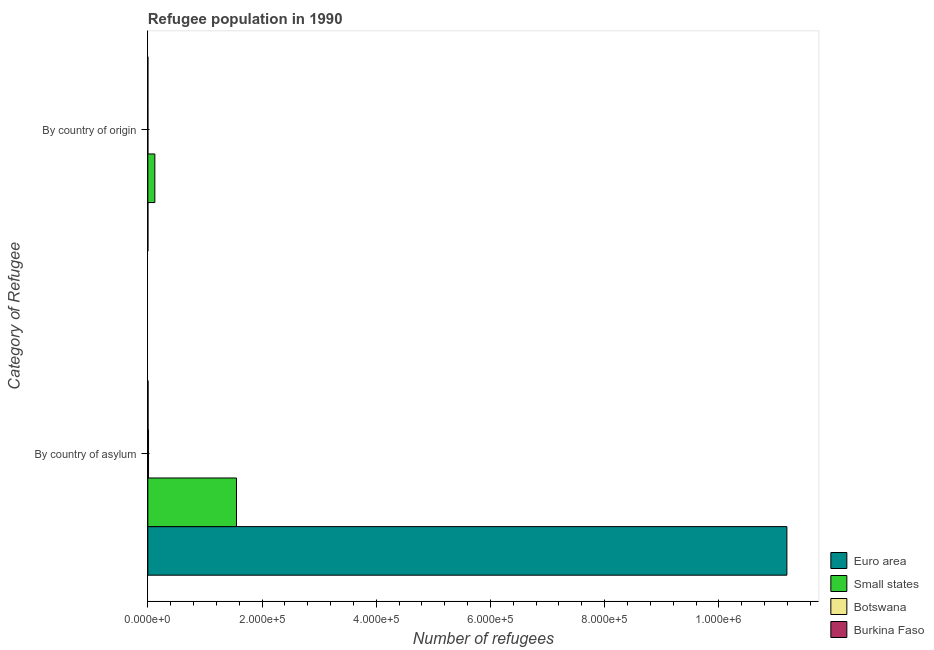Are the number of bars per tick equal to the number of legend labels?
Make the answer very short. Yes. Are the number of bars on each tick of the Y-axis equal?
Your answer should be compact. Yes. How many bars are there on the 2nd tick from the top?
Keep it short and to the point. 4. How many bars are there on the 1st tick from the bottom?
Give a very brief answer. 4. What is the label of the 1st group of bars from the top?
Keep it short and to the point. By country of origin. What is the number of refugees by country of origin in Botswana?
Ensure brevity in your answer.  3. Across all countries, what is the maximum number of refugees by country of asylum?
Ensure brevity in your answer.  1.12e+06. Across all countries, what is the minimum number of refugees by country of origin?
Make the answer very short. 2. In which country was the number of refugees by country of origin maximum?
Your response must be concise. Small states. In which country was the number of refugees by country of origin minimum?
Provide a succinct answer. Burkina Faso. What is the total number of refugees by country of origin in the graph?
Provide a succinct answer. 1.23e+04. What is the difference between the number of refugees by country of origin in Euro area and that in Small states?
Your answer should be very brief. -1.22e+04. What is the difference between the number of refugees by country of origin in Small states and the number of refugees by country of asylum in Euro area?
Provide a short and direct response. -1.11e+06. What is the average number of refugees by country of asylum per country?
Offer a terse response. 3.19e+05. What is the difference between the number of refugees by country of asylum and number of refugees by country of origin in Euro area?
Offer a very short reply. 1.12e+06. In how many countries, is the number of refugees by country of asylum greater than 720000 ?
Your answer should be very brief. 1. What is the ratio of the number of refugees by country of origin in Small states to that in Burkina Faso?
Your answer should be compact. 6122.5. Is the number of refugees by country of asylum in Botswana less than that in Euro area?
Provide a succinct answer. Yes. What does the 3rd bar from the top in By country of asylum represents?
Offer a terse response. Small states. What does the 3rd bar from the bottom in By country of asylum represents?
Keep it short and to the point. Botswana. How many bars are there?
Give a very brief answer. 8. How many countries are there in the graph?
Provide a short and direct response. 4. What is the difference between two consecutive major ticks on the X-axis?
Ensure brevity in your answer.  2.00e+05. Does the graph contain any zero values?
Offer a terse response. No. Does the graph contain grids?
Provide a succinct answer. No. Where does the legend appear in the graph?
Your answer should be compact. Bottom right. How many legend labels are there?
Offer a terse response. 4. What is the title of the graph?
Keep it short and to the point. Refugee population in 1990. What is the label or title of the X-axis?
Keep it short and to the point. Number of refugees. What is the label or title of the Y-axis?
Provide a short and direct response. Category of Refugee. What is the Number of refugees in Euro area in By country of asylum?
Ensure brevity in your answer.  1.12e+06. What is the Number of refugees of Small states in By country of asylum?
Make the answer very short. 1.55e+05. What is the Number of refugees of Botswana in By country of asylum?
Provide a succinct answer. 1179. What is the Number of refugees in Burkina Faso in By country of asylum?
Give a very brief answer. 350. What is the Number of refugees in Small states in By country of origin?
Your answer should be compact. 1.22e+04. What is the Number of refugees of Botswana in By country of origin?
Your response must be concise. 3. What is the Number of refugees of Burkina Faso in By country of origin?
Offer a very short reply. 2. Across all Category of Refugee, what is the maximum Number of refugees of Euro area?
Give a very brief answer. 1.12e+06. Across all Category of Refugee, what is the maximum Number of refugees of Small states?
Provide a short and direct response. 1.55e+05. Across all Category of Refugee, what is the maximum Number of refugees in Botswana?
Ensure brevity in your answer.  1179. Across all Category of Refugee, what is the maximum Number of refugees in Burkina Faso?
Provide a short and direct response. 350. Across all Category of Refugee, what is the minimum Number of refugees of Small states?
Keep it short and to the point. 1.22e+04. Across all Category of Refugee, what is the minimum Number of refugees in Botswana?
Keep it short and to the point. 3. What is the total Number of refugees of Euro area in the graph?
Your answer should be compact. 1.12e+06. What is the total Number of refugees of Small states in the graph?
Make the answer very short. 1.67e+05. What is the total Number of refugees in Botswana in the graph?
Your response must be concise. 1182. What is the total Number of refugees in Burkina Faso in the graph?
Offer a terse response. 352. What is the difference between the Number of refugees in Euro area in By country of asylum and that in By country of origin?
Make the answer very short. 1.12e+06. What is the difference between the Number of refugees in Small states in By country of asylum and that in By country of origin?
Provide a succinct answer. 1.43e+05. What is the difference between the Number of refugees in Botswana in By country of asylum and that in By country of origin?
Your answer should be compact. 1176. What is the difference between the Number of refugees of Burkina Faso in By country of asylum and that in By country of origin?
Provide a short and direct response. 348. What is the difference between the Number of refugees of Euro area in By country of asylum and the Number of refugees of Small states in By country of origin?
Provide a short and direct response. 1.11e+06. What is the difference between the Number of refugees of Euro area in By country of asylum and the Number of refugees of Botswana in By country of origin?
Offer a terse response. 1.12e+06. What is the difference between the Number of refugees in Euro area in By country of asylum and the Number of refugees in Burkina Faso in By country of origin?
Provide a short and direct response. 1.12e+06. What is the difference between the Number of refugees of Small states in By country of asylum and the Number of refugees of Botswana in By country of origin?
Your answer should be compact. 1.55e+05. What is the difference between the Number of refugees of Small states in By country of asylum and the Number of refugees of Burkina Faso in By country of origin?
Your response must be concise. 1.55e+05. What is the difference between the Number of refugees in Botswana in By country of asylum and the Number of refugees in Burkina Faso in By country of origin?
Your response must be concise. 1177. What is the average Number of refugees in Euro area per Category of Refugee?
Your answer should be compact. 5.60e+05. What is the average Number of refugees of Small states per Category of Refugee?
Provide a short and direct response. 8.37e+04. What is the average Number of refugees in Botswana per Category of Refugee?
Your answer should be compact. 591. What is the average Number of refugees in Burkina Faso per Category of Refugee?
Ensure brevity in your answer.  176. What is the difference between the Number of refugees of Euro area and Number of refugees of Small states in By country of asylum?
Give a very brief answer. 9.64e+05. What is the difference between the Number of refugees in Euro area and Number of refugees in Botswana in By country of asylum?
Offer a terse response. 1.12e+06. What is the difference between the Number of refugees of Euro area and Number of refugees of Burkina Faso in By country of asylum?
Keep it short and to the point. 1.12e+06. What is the difference between the Number of refugees of Small states and Number of refugees of Botswana in By country of asylum?
Provide a succinct answer. 1.54e+05. What is the difference between the Number of refugees of Small states and Number of refugees of Burkina Faso in By country of asylum?
Make the answer very short. 1.55e+05. What is the difference between the Number of refugees of Botswana and Number of refugees of Burkina Faso in By country of asylum?
Offer a very short reply. 829. What is the difference between the Number of refugees of Euro area and Number of refugees of Small states in By country of origin?
Provide a succinct answer. -1.22e+04. What is the difference between the Number of refugees in Euro area and Number of refugees in Botswana in By country of origin?
Ensure brevity in your answer.  29. What is the difference between the Number of refugees in Small states and Number of refugees in Botswana in By country of origin?
Offer a very short reply. 1.22e+04. What is the difference between the Number of refugees in Small states and Number of refugees in Burkina Faso in By country of origin?
Offer a very short reply. 1.22e+04. What is the ratio of the Number of refugees in Euro area in By country of asylum to that in By country of origin?
Keep it short and to the point. 3.50e+04. What is the ratio of the Number of refugees in Small states in By country of asylum to that in By country of origin?
Ensure brevity in your answer.  12.68. What is the ratio of the Number of refugees in Botswana in By country of asylum to that in By country of origin?
Offer a terse response. 393. What is the ratio of the Number of refugees of Burkina Faso in By country of asylum to that in By country of origin?
Give a very brief answer. 175. What is the difference between the highest and the second highest Number of refugees of Euro area?
Your answer should be very brief. 1.12e+06. What is the difference between the highest and the second highest Number of refugees of Small states?
Your answer should be compact. 1.43e+05. What is the difference between the highest and the second highest Number of refugees in Botswana?
Provide a short and direct response. 1176. What is the difference between the highest and the second highest Number of refugees in Burkina Faso?
Provide a short and direct response. 348. What is the difference between the highest and the lowest Number of refugees in Euro area?
Your answer should be very brief. 1.12e+06. What is the difference between the highest and the lowest Number of refugees of Small states?
Give a very brief answer. 1.43e+05. What is the difference between the highest and the lowest Number of refugees of Botswana?
Offer a very short reply. 1176. What is the difference between the highest and the lowest Number of refugees of Burkina Faso?
Provide a succinct answer. 348. 